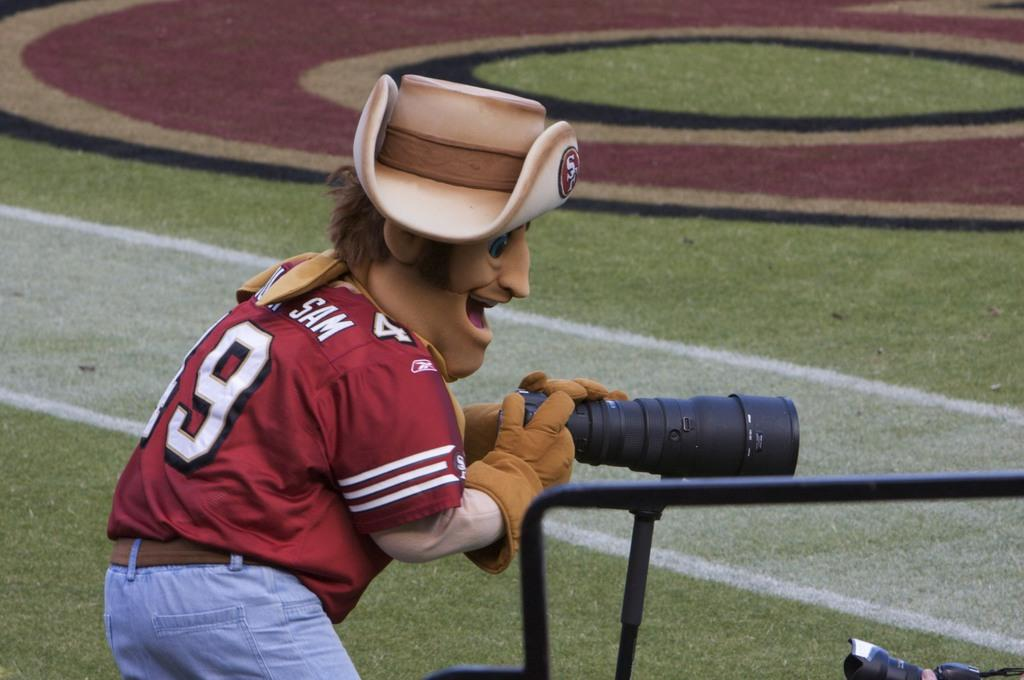What can be seen in the image related to a person? There is a person in the image. What is the person wearing on their head? The person is wearing a hat. What type of clothing is the person wearing? The person is wearing some costumes. What is the person holding in the image? The person is holding a camera. What type of ground is visible in the image? There is grass at the bottom of the image. What other objects can be seen in the image? There are sticks in the image. Where is the lift located in the image? There is no lift present in the image. What type of band is playing in the image? There is no band present in the image. 